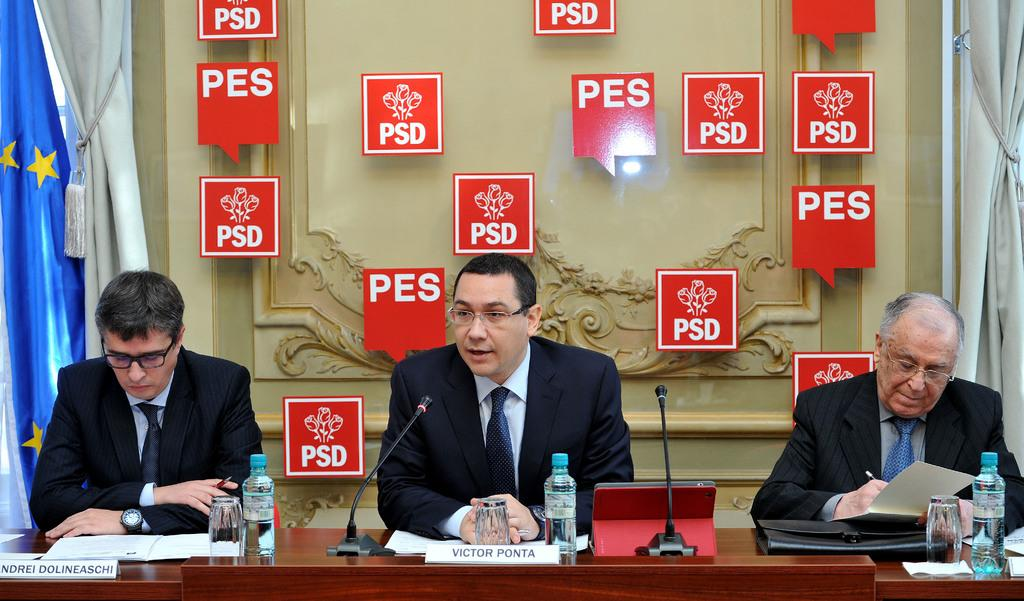Provide a one-sentence caption for the provided image. three men sitting in front of a wall with red signs that say 'pes' on some of them. 